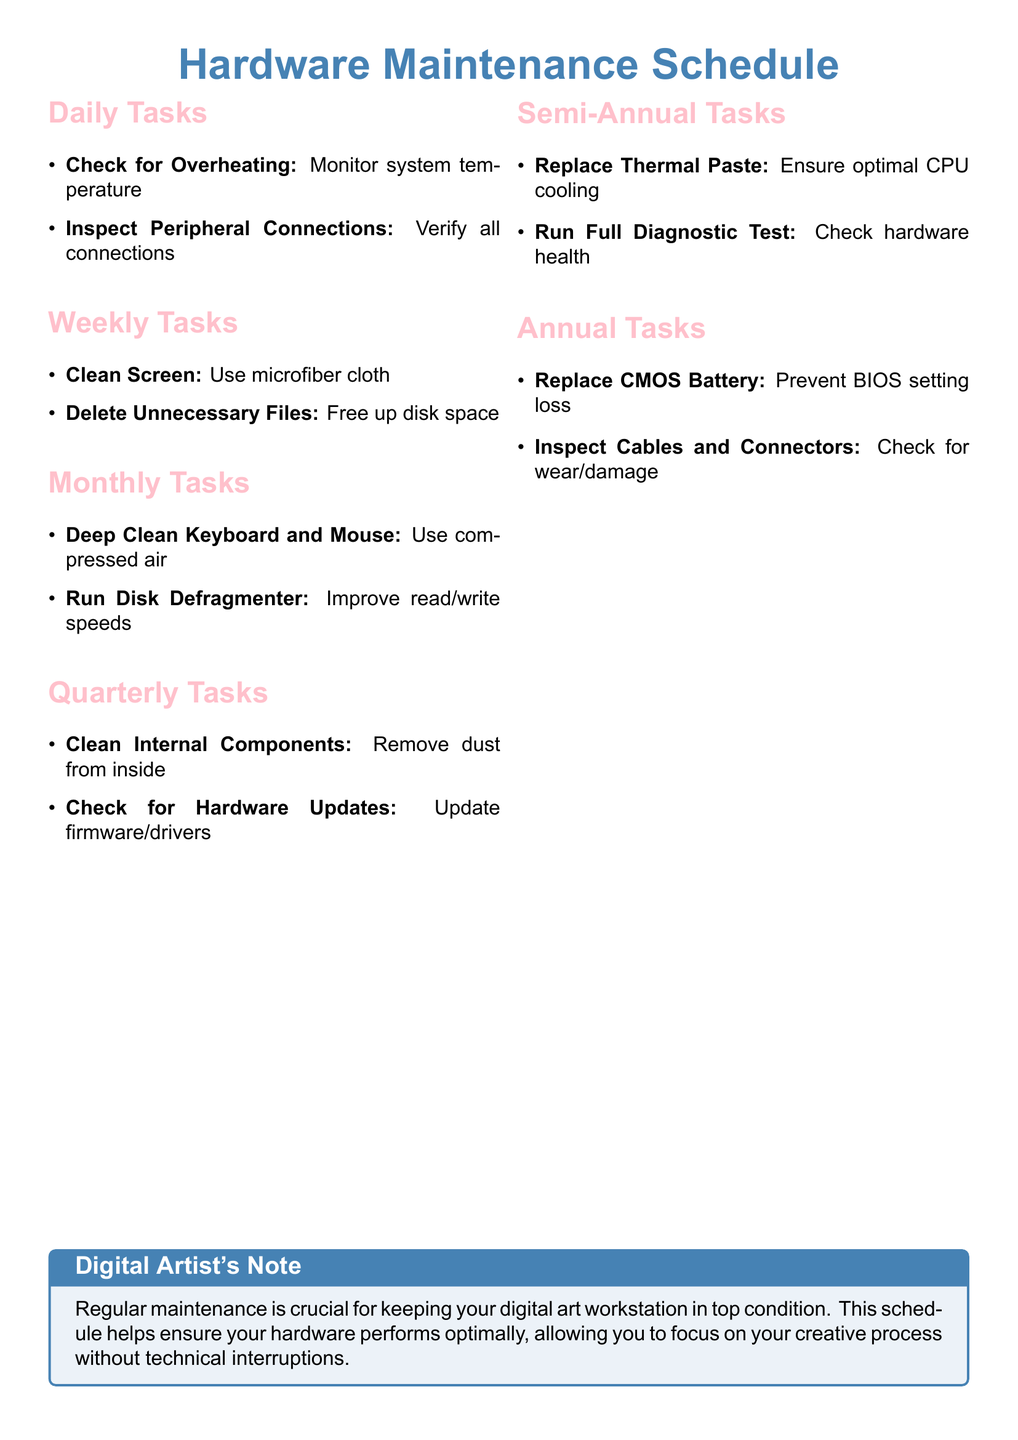What are the daily tasks? The daily tasks include monitoring system temperature and verifying all connections.
Answer: Check for Overheating, Inspect Peripheral Connections How often should you clean internal components? The document states that cleaning internal components should be done quarterly.
Answer: Quarterly What is included in the semi-annual tasks? The semi-annual tasks involve replacing thermal paste and running a full diagnostic test.
Answer: Replace Thermal Paste, Run Full Diagnostic Test How many total categories of tasks are outlined? The document has six categories: Daily, Weekly, Monthly, Quarterly, Semi-Annual, and Annual tasks.
Answer: Six What task is suggested for improving read/write speeds? The document suggests running a disk defragmenter to improve read/write speeds.
Answer: Run Disk Defragmenter When should you inspect cables and connectors? According to the document, cables and connectors should be inspected annually.
Answer: Annually What equipment should be used for cleaning the screen weekly? The recommended equipment for cleaning the screen weekly is a microfiber cloth.
Answer: Microfiber cloth What is the purpose of replacing the CMOS battery? The CMOS battery is replaced to prevent loss of BIOS settings.
Answer: Prevent BIOS setting loss What is the color scheme used for task sections? The sections for tasks are colored in art pink.
Answer: Art pink 